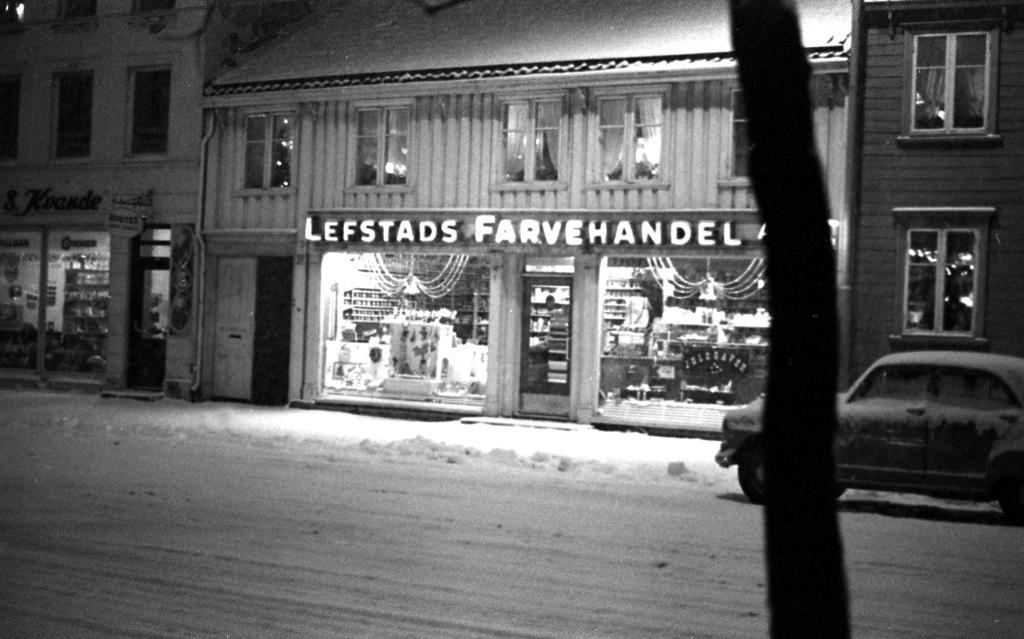Could you give a brief overview of what you see in this image? We can see tree trunk and car on the surface. In the background we can see buildings,windows and door. 